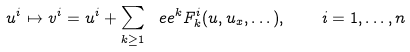Convert formula to latex. <formula><loc_0><loc_0><loc_500><loc_500>u ^ { i } \mapsto { v } ^ { i } = u ^ { i } + \sum _ { k \geq 1 } \ e e ^ { k } F ^ { i } _ { k } ( { u } , { u } _ { x } , \dots ) , \quad i = 1 , \dots , n</formula> 